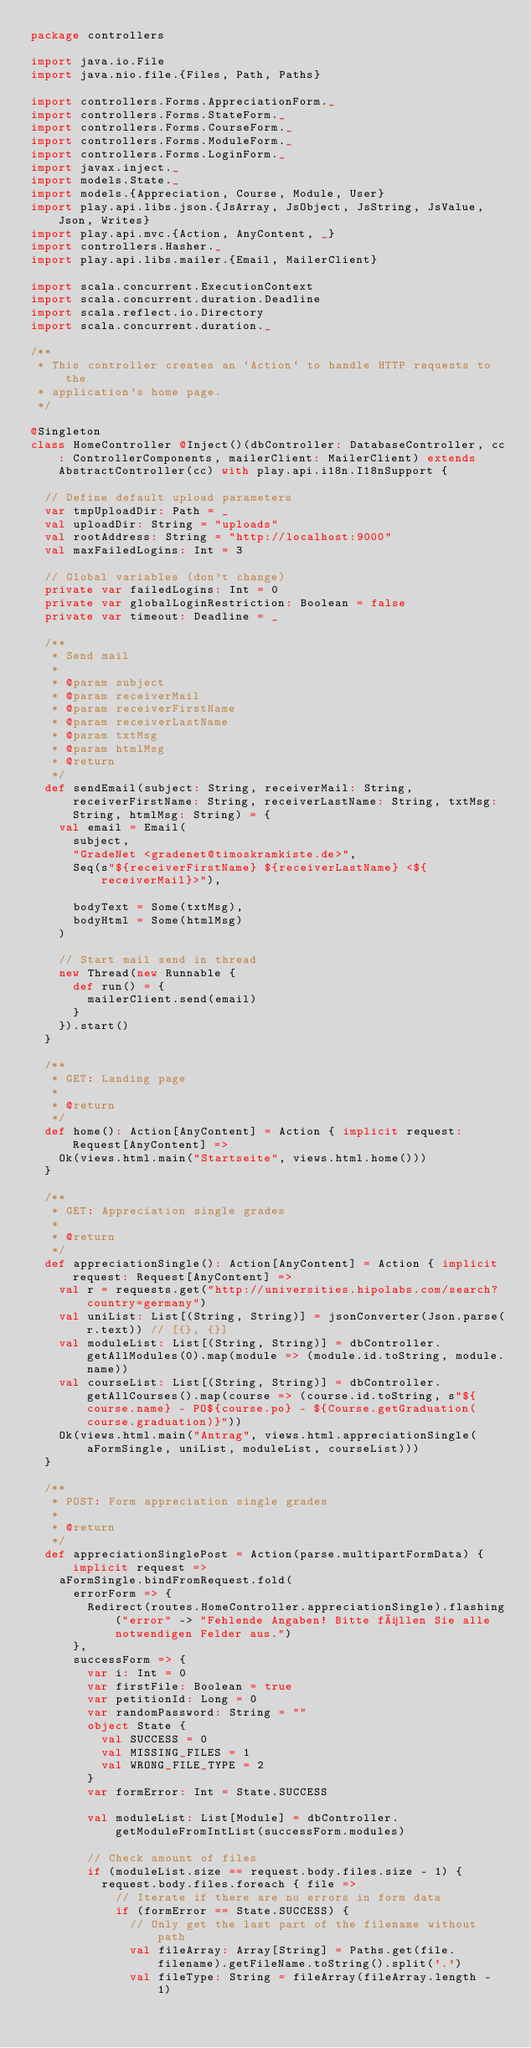Convert code to text. <code><loc_0><loc_0><loc_500><loc_500><_Scala_>package controllers

import java.io.File
import java.nio.file.{Files, Path, Paths}

import controllers.Forms.AppreciationForm._
import controllers.Forms.StateForm._
import controllers.Forms.CourseForm._
import controllers.Forms.ModuleForm._
import controllers.Forms.LoginForm._
import javax.inject._
import models.State._
import models.{Appreciation, Course, Module, User}
import play.api.libs.json.{JsArray, JsObject, JsString, JsValue, Json, Writes}
import play.api.mvc.{Action, AnyContent, _}
import controllers.Hasher._
import play.api.libs.mailer.{Email, MailerClient}

import scala.concurrent.ExecutionContext
import scala.concurrent.duration.Deadline
import scala.reflect.io.Directory
import scala.concurrent.duration._

/**
 * This controller creates an `Action` to handle HTTP requests to the
 * application's home page.
 */

@Singleton
class HomeController @Inject()(dbController: DatabaseController, cc: ControllerComponents, mailerClient: MailerClient) extends AbstractController(cc) with play.api.i18n.I18nSupport {

  // Define default upload parameters
  var tmpUploadDir: Path = _
  val uploadDir: String = "uploads"
  val rootAddress: String = "http://localhost:9000"
  val maxFailedLogins: Int = 3

  // Global variables (don't change)
  private var failedLogins: Int = 0
  private var globalLoginRestriction: Boolean = false
  private var timeout: Deadline = _

  /**
   * Send mail
   *
   * @param subject
   * @param receiverMail
   * @param receiverFirstName
   * @param receiverLastName
   * @param txtMsg
   * @param htmlMsg
   * @return
   */
  def sendEmail(subject: String, receiverMail: String, receiverFirstName: String, receiverLastName: String, txtMsg: String, htmlMsg: String) = {
    val email = Email(
      subject,
      "GradeNet <gradenet@timoskramkiste.de>",
      Seq(s"${receiverFirstName} ${receiverLastName} <${receiverMail}>"),

      bodyText = Some(txtMsg),
      bodyHtml = Some(htmlMsg)
    )

    // Start mail send in thread
    new Thread(new Runnable {
      def run() = {
        mailerClient.send(email)
      }
    }).start()
  }

  /**
   * GET: Landing page
   *
   * @return
   */
  def home(): Action[AnyContent] = Action { implicit request: Request[AnyContent] =>
    Ok(views.html.main("Startseite", views.html.home()))
  }

  /**
   * GET: Appreciation single grades
   *
   * @return
   */
  def appreciationSingle(): Action[AnyContent] = Action { implicit request: Request[AnyContent] =>
    val r = requests.get("http://universities.hipolabs.com/search?country=germany")
    val uniList: List[(String, String)] = jsonConverter(Json.parse(r.text)) // [{}, {}]
    val moduleList: List[(String, String)] = dbController.getAllModules(0).map(module => (module.id.toString, module.name))
    val courseList: List[(String, String)] = dbController.getAllCourses().map(course => (course.id.toString, s"${course.name} - PO${course.po} - ${Course.getGraduation(course.graduation)}"))
    Ok(views.html.main("Antrag", views.html.appreciationSingle(aFormSingle, uniList, moduleList, courseList)))
  }

  /**
   * POST: Form appreciation single grades
   *
   * @return
   */
  def appreciationSinglePost = Action(parse.multipartFormData) { implicit request =>
    aFormSingle.bindFromRequest.fold(
      errorForm => {
        Redirect(routes.HomeController.appreciationSingle).flashing("error" -> "Fehlende Angaben! Bitte füllen Sie alle notwendigen Felder aus.")
      },
      successForm => {
        var i: Int = 0
        var firstFile: Boolean = true
        var petitionId: Long = 0
        var randomPassword: String = ""
        object State {
          val SUCCESS = 0
          val MISSING_FILES = 1
          val WRONG_FILE_TYPE = 2
        }
        var formError: Int = State.SUCCESS

        val moduleList: List[Module] = dbController.getModuleFromIntList(successForm.modules)

        // Check amount of files
        if (moduleList.size == request.body.files.size - 1) {
          request.body.files.foreach { file =>
            // Iterate if there are no errors in form data
            if (formError == State.SUCCESS) {
              // Only get the last part of the filename without path
              val fileArray: Array[String] = Paths.get(file.filename).getFileName.toString().split('.')
              val fileType: String = fileArray(fileArray.length - 1)
</code> 